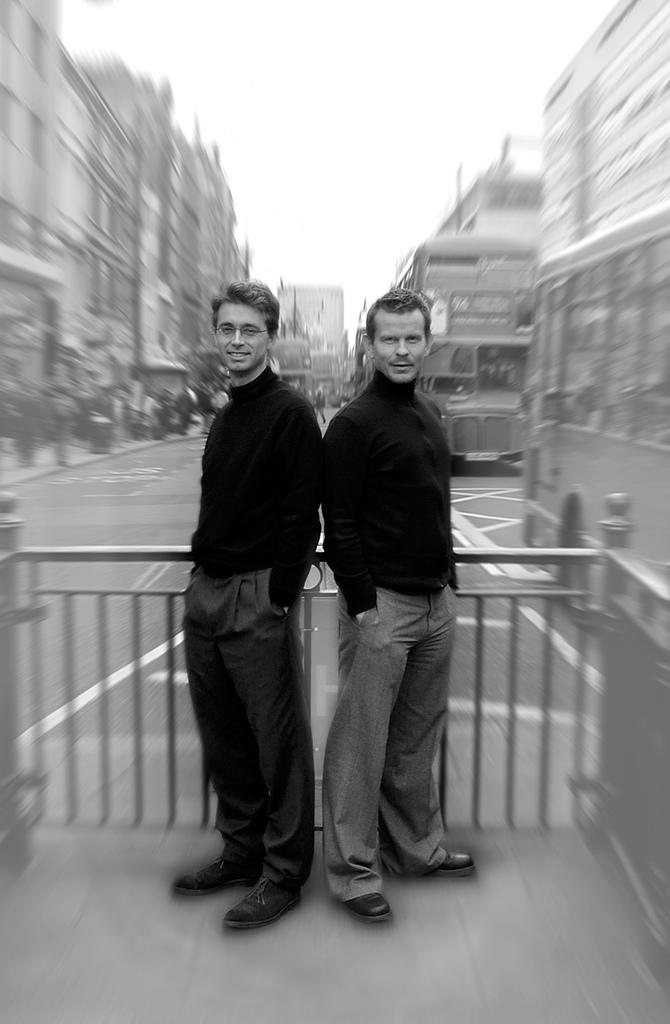How many people are present in the image? There are two people in the image. What are the people wearing? The people are wearing black color shirts. What can be seen in the background of the image? There is a fence, buildings, and the sky visible in the image. What type of map can be seen in the image? There is no map present in the image. What kind of feeling does the fence evoke in the image? The image is not capable of conveying feelings, and the fence is an inanimate object. 